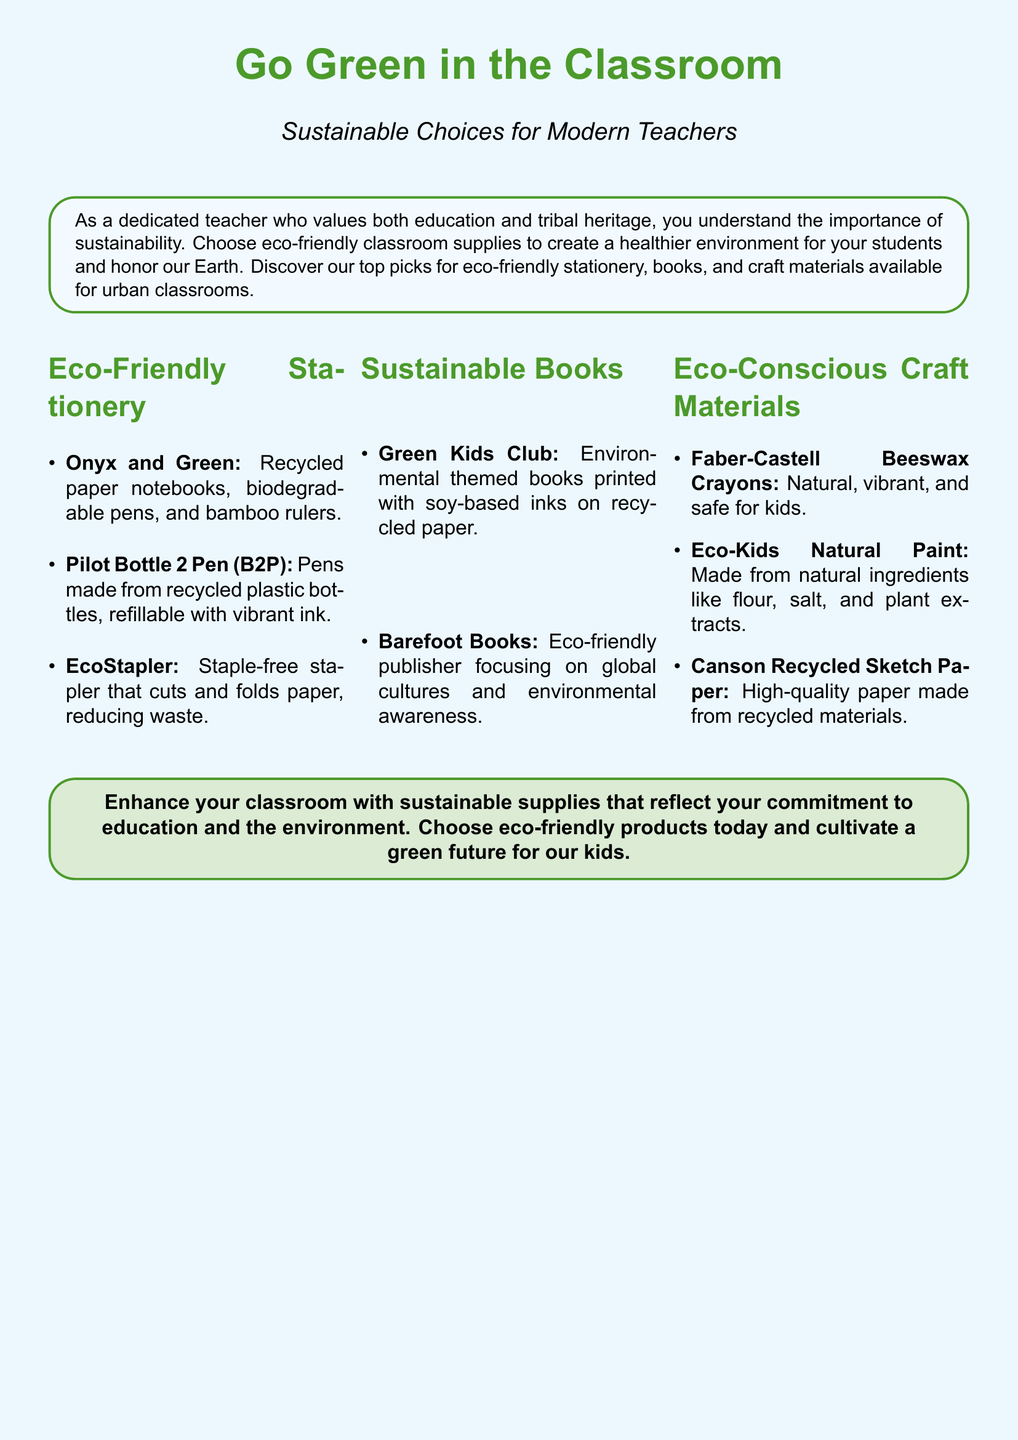what is the title of the advertisement? The title of the advertisement is prominently displayed at the top of the document, highlighting the theme of sustainability in education.
Answer: Go Green in the Classroom who is the target audience for these eco-friendly supplies? The advertisement mentions teachers who value both education and tribal heritage, suggesting a specific audience.
Answer: modern teachers what kind of stationery is mentioned? The document lists specific products that fall under the category of eco-friendly stationery.
Answer: recycled paper notebooks which company produces the EcoStapler? The name of the specific product is included in the stationery section without mentioning a company.
Answer: EcoStapler what type of books does the Barefoot Books publisher focus on? The advertisement states the primary focus of Barefoot Books, which is indicative of its content.
Answer: global cultures and environmental awareness how are the Faber-Castell Beeswax Crayons described? The document provides descriptive characteristics of these particular craft materials.
Answer: natural, vibrant, and safe for kids how many categories of eco-friendly supplies are mentioned in the document? By counting the categories listed in the advertisement, one can determine the number of distinct sections.
Answer: three what is the color scheme used for the title? The document features specific color choices for different text elements, particularly for the title.
Answer: leafgreen 